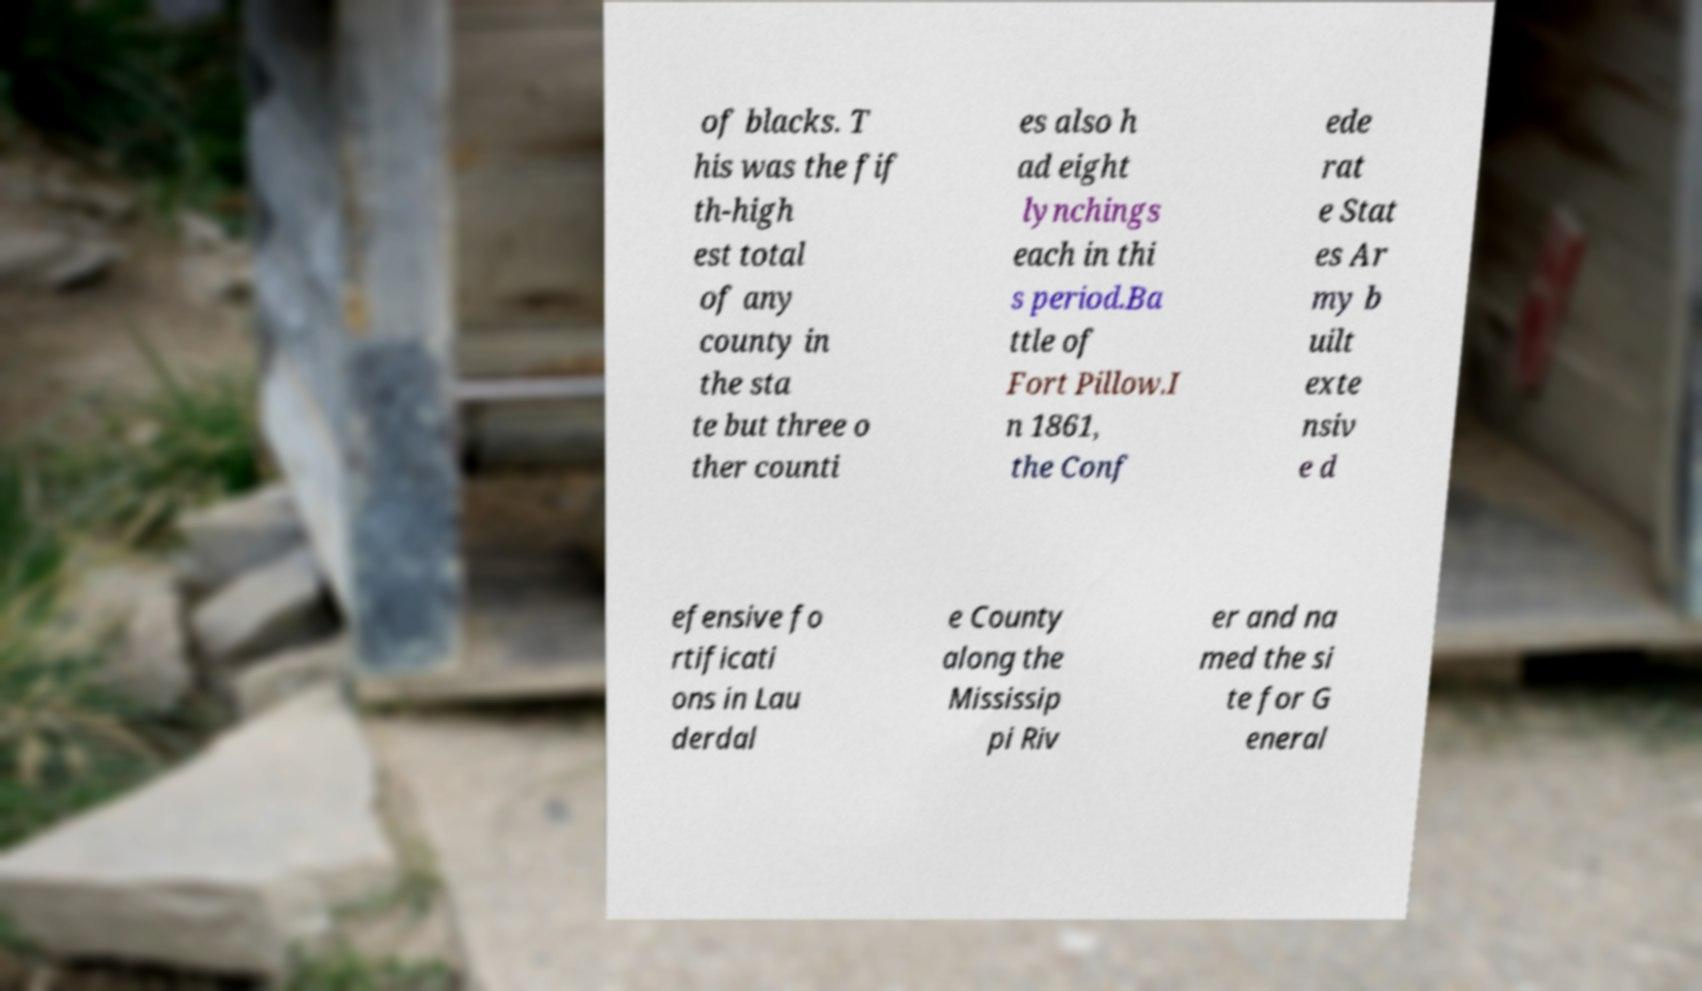Please read and relay the text visible in this image. What does it say? of blacks. T his was the fif th-high est total of any county in the sta te but three o ther counti es also h ad eight lynchings each in thi s period.Ba ttle of Fort Pillow.I n 1861, the Conf ede rat e Stat es Ar my b uilt exte nsiv e d efensive fo rtificati ons in Lau derdal e County along the Mississip pi Riv er and na med the si te for G eneral 